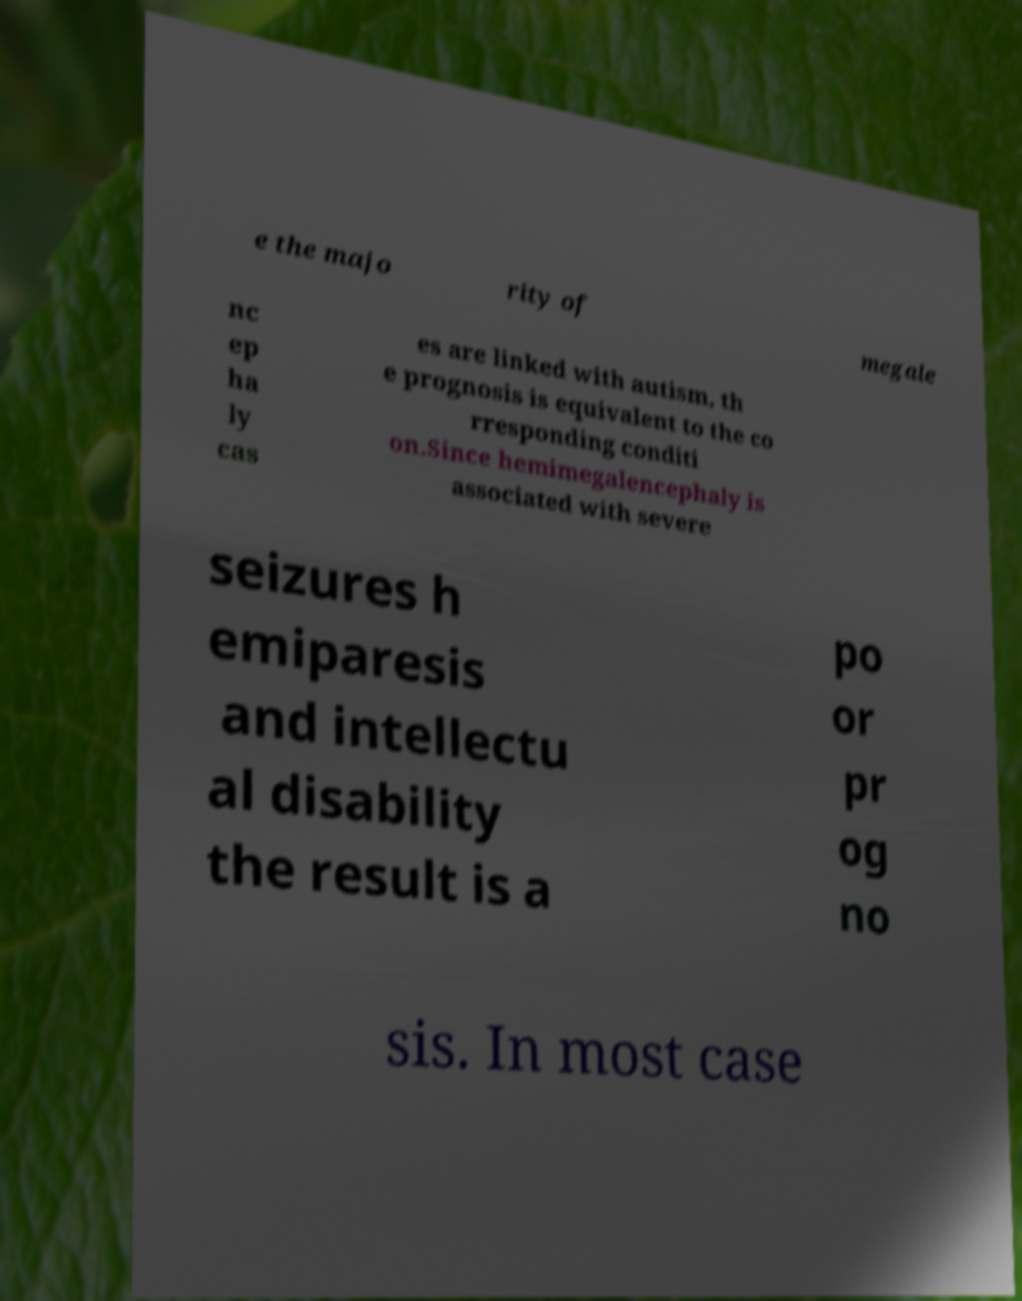What messages or text are displayed in this image? I need them in a readable, typed format. e the majo rity of megale nc ep ha ly cas es are linked with autism, th e prognosis is equivalent to the co rresponding conditi on.Since hemimegalencephaly is associated with severe seizures h emiparesis and intellectu al disability the result is a po or pr og no sis. In most case 